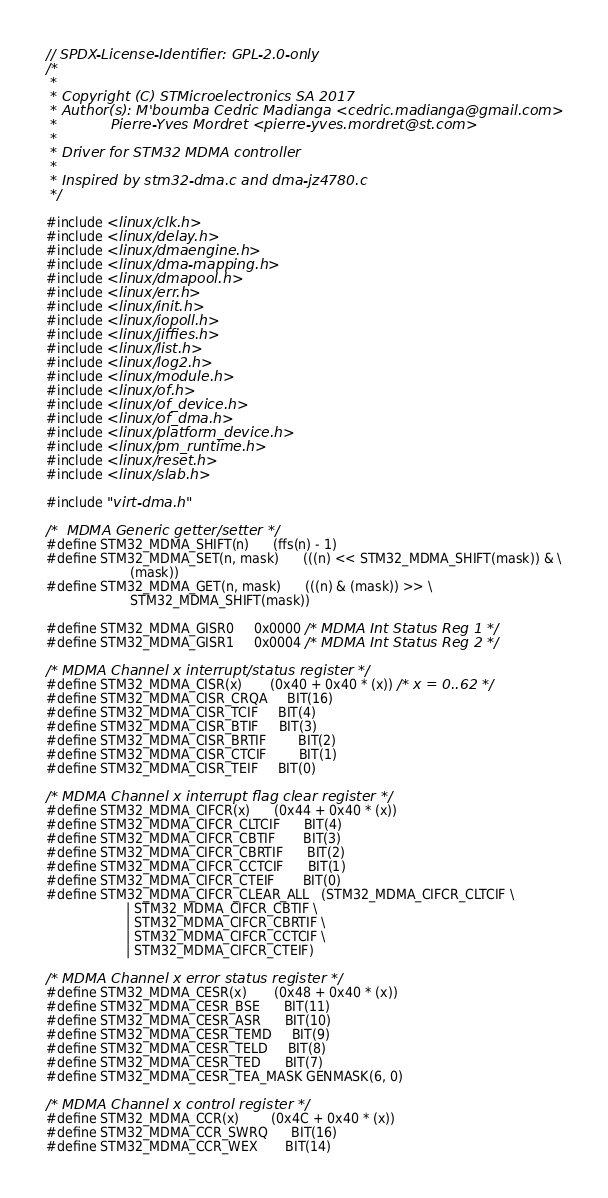Convert code to text. <code><loc_0><loc_0><loc_500><loc_500><_C_>// SPDX-License-Identifier: GPL-2.0-only
/*
 *
 * Copyright (C) STMicroelectronics SA 2017
 * Author(s): M'boumba Cedric Madianga <cedric.madianga@gmail.com>
 *            Pierre-Yves Mordret <pierre-yves.mordret@st.com>
 *
 * Driver for STM32 MDMA controller
 *
 * Inspired by stm32-dma.c and dma-jz4780.c
 */

#include <linux/clk.h>
#include <linux/delay.h>
#include <linux/dmaengine.h>
#include <linux/dma-mapping.h>
#include <linux/dmapool.h>
#include <linux/err.h>
#include <linux/init.h>
#include <linux/iopoll.h>
#include <linux/jiffies.h>
#include <linux/list.h>
#include <linux/log2.h>
#include <linux/module.h>
#include <linux/of.h>
#include <linux/of_device.h>
#include <linux/of_dma.h>
#include <linux/platform_device.h>
#include <linux/pm_runtime.h>
#include <linux/reset.h>
#include <linux/slab.h>

#include "virt-dma.h"

/*  MDMA Generic getter/setter */
#define STM32_MDMA_SHIFT(n)		(ffs(n) - 1)
#define STM32_MDMA_SET(n, mask)		(((n) << STM32_MDMA_SHIFT(mask)) & \
					 (mask))
#define STM32_MDMA_GET(n, mask)		(((n) & (mask)) >> \
					 STM32_MDMA_SHIFT(mask))

#define STM32_MDMA_GISR0		0x0000 /* MDMA Int Status Reg 1 */
#define STM32_MDMA_GISR1		0x0004 /* MDMA Int Status Reg 2 */

/* MDMA Channel x interrupt/status register */
#define STM32_MDMA_CISR(x)		(0x40 + 0x40 * (x)) /* x = 0..62 */
#define STM32_MDMA_CISR_CRQA		BIT(16)
#define STM32_MDMA_CISR_TCIF		BIT(4)
#define STM32_MDMA_CISR_BTIF		BIT(3)
#define STM32_MDMA_CISR_BRTIF		BIT(2)
#define STM32_MDMA_CISR_CTCIF		BIT(1)
#define STM32_MDMA_CISR_TEIF		BIT(0)

/* MDMA Channel x interrupt flag clear register */
#define STM32_MDMA_CIFCR(x)		(0x44 + 0x40 * (x))
#define STM32_MDMA_CIFCR_CLTCIF		BIT(4)
#define STM32_MDMA_CIFCR_CBTIF		BIT(3)
#define STM32_MDMA_CIFCR_CBRTIF		BIT(2)
#define STM32_MDMA_CIFCR_CCTCIF		BIT(1)
#define STM32_MDMA_CIFCR_CTEIF		BIT(0)
#define STM32_MDMA_CIFCR_CLEAR_ALL	(STM32_MDMA_CIFCR_CLTCIF \
					| STM32_MDMA_CIFCR_CBTIF \
					| STM32_MDMA_CIFCR_CBRTIF \
					| STM32_MDMA_CIFCR_CCTCIF \
					| STM32_MDMA_CIFCR_CTEIF)

/* MDMA Channel x error status register */
#define STM32_MDMA_CESR(x)		(0x48 + 0x40 * (x))
#define STM32_MDMA_CESR_BSE		BIT(11)
#define STM32_MDMA_CESR_ASR		BIT(10)
#define STM32_MDMA_CESR_TEMD		BIT(9)
#define STM32_MDMA_CESR_TELD		BIT(8)
#define STM32_MDMA_CESR_TED		BIT(7)
#define STM32_MDMA_CESR_TEA_MASK	GENMASK(6, 0)

/* MDMA Channel x control register */
#define STM32_MDMA_CCR(x)		(0x4C + 0x40 * (x))
#define STM32_MDMA_CCR_SWRQ		BIT(16)
#define STM32_MDMA_CCR_WEX		BIT(14)</code> 